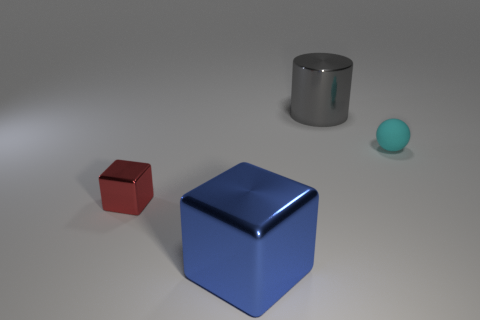Add 1 large brown metallic spheres. How many objects exist? 5 Subtract 1 cubes. How many cubes are left? 1 Subtract all balls. How many objects are left? 3 Subtract all red cubes. How many cubes are left? 1 Subtract 0 yellow cylinders. How many objects are left? 4 Subtract all yellow blocks. Subtract all yellow cylinders. How many blocks are left? 2 Subtract all blue cylinders. Subtract all large shiny blocks. How many objects are left? 3 Add 2 blue metal blocks. How many blue metal blocks are left? 3 Add 2 large blue matte cylinders. How many large blue matte cylinders exist? 2 